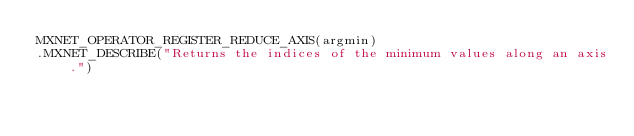<code> <loc_0><loc_0><loc_500><loc_500><_C++_>MXNET_OPERATOR_REGISTER_REDUCE_AXIS(argmin)
.MXNET_DESCRIBE("Returns the indices of the minimum values along an axis.")</code> 